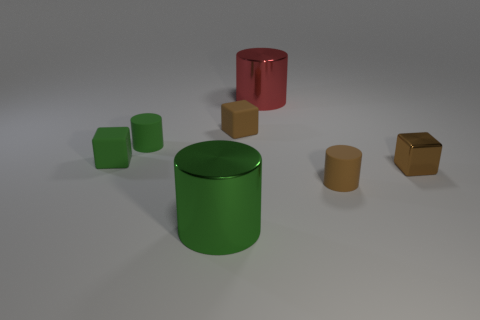Subtract all tiny brown cylinders. How many cylinders are left? 3 Subtract all brown cylinders. How many cylinders are left? 3 Add 3 tiny green rubber cylinders. How many objects exist? 10 Subtract all cylinders. How many objects are left? 3 Subtract all blue spheres. How many brown cubes are left? 2 Add 1 small cylinders. How many small cylinders exist? 3 Subtract 0 purple balls. How many objects are left? 7 Subtract 1 cubes. How many cubes are left? 2 Subtract all cyan cylinders. Subtract all red blocks. How many cylinders are left? 4 Subtract all small green rubber cylinders. Subtract all small green metallic things. How many objects are left? 6 